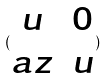Convert formula to latex. <formula><loc_0><loc_0><loc_500><loc_500>( \begin{matrix} u & 0 \\ a z & u \end{matrix} )</formula> 